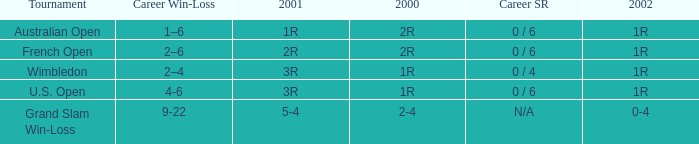In what year 2000 tournment did Angeles Montolio have a career win-loss record of 2-4? Grand Slam Win-Loss. Could you help me parse every detail presented in this table? {'header': ['Tournament', 'Career Win-Loss', '2001', '2000', 'Career SR', '2002'], 'rows': [['Australian Open', '1–6', '1R', '2R', '0 / 6', '1R'], ['French Open', '2–6', '2R', '2R', '0 / 6', '1R'], ['Wimbledon', '2–4', '3R', '1R', '0 / 4', '1R'], ['U.S. Open', '4-6', '3R', '1R', '0 / 6', '1R'], ['Grand Slam Win-Loss', '9-22', '5-4', '2-4', 'N/A', '0-4']]} 